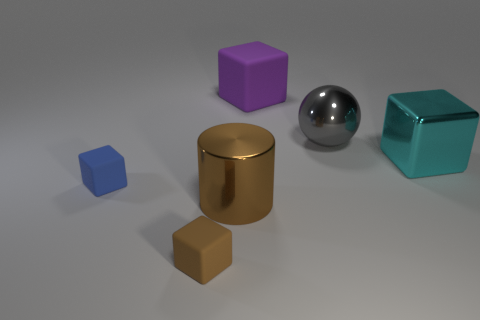What is the shape of the gray thing?
Offer a terse response. Sphere. There is a tiny matte thing that is in front of the brown cylinder; is its color the same as the large metal cylinder?
Provide a succinct answer. Yes. What is the size of the blue thing that is the same shape as the large purple object?
Provide a short and direct response. Small. There is a matte thing in front of the tiny object that is behind the tiny brown rubber object; are there any objects to the right of it?
Keep it short and to the point. Yes. There is a big cube that is left of the gray shiny sphere; what is its material?
Provide a succinct answer. Rubber. What number of large things are blue blocks or yellow objects?
Give a very brief answer. 0. Is the size of the metal object in front of the cyan shiny cube the same as the blue matte object?
Your response must be concise. No. What number of other objects are the same color as the cylinder?
Make the answer very short. 1. What is the brown cube made of?
Your answer should be compact. Rubber. What material is the thing that is in front of the blue matte cube and behind the small brown object?
Your response must be concise. Metal. 